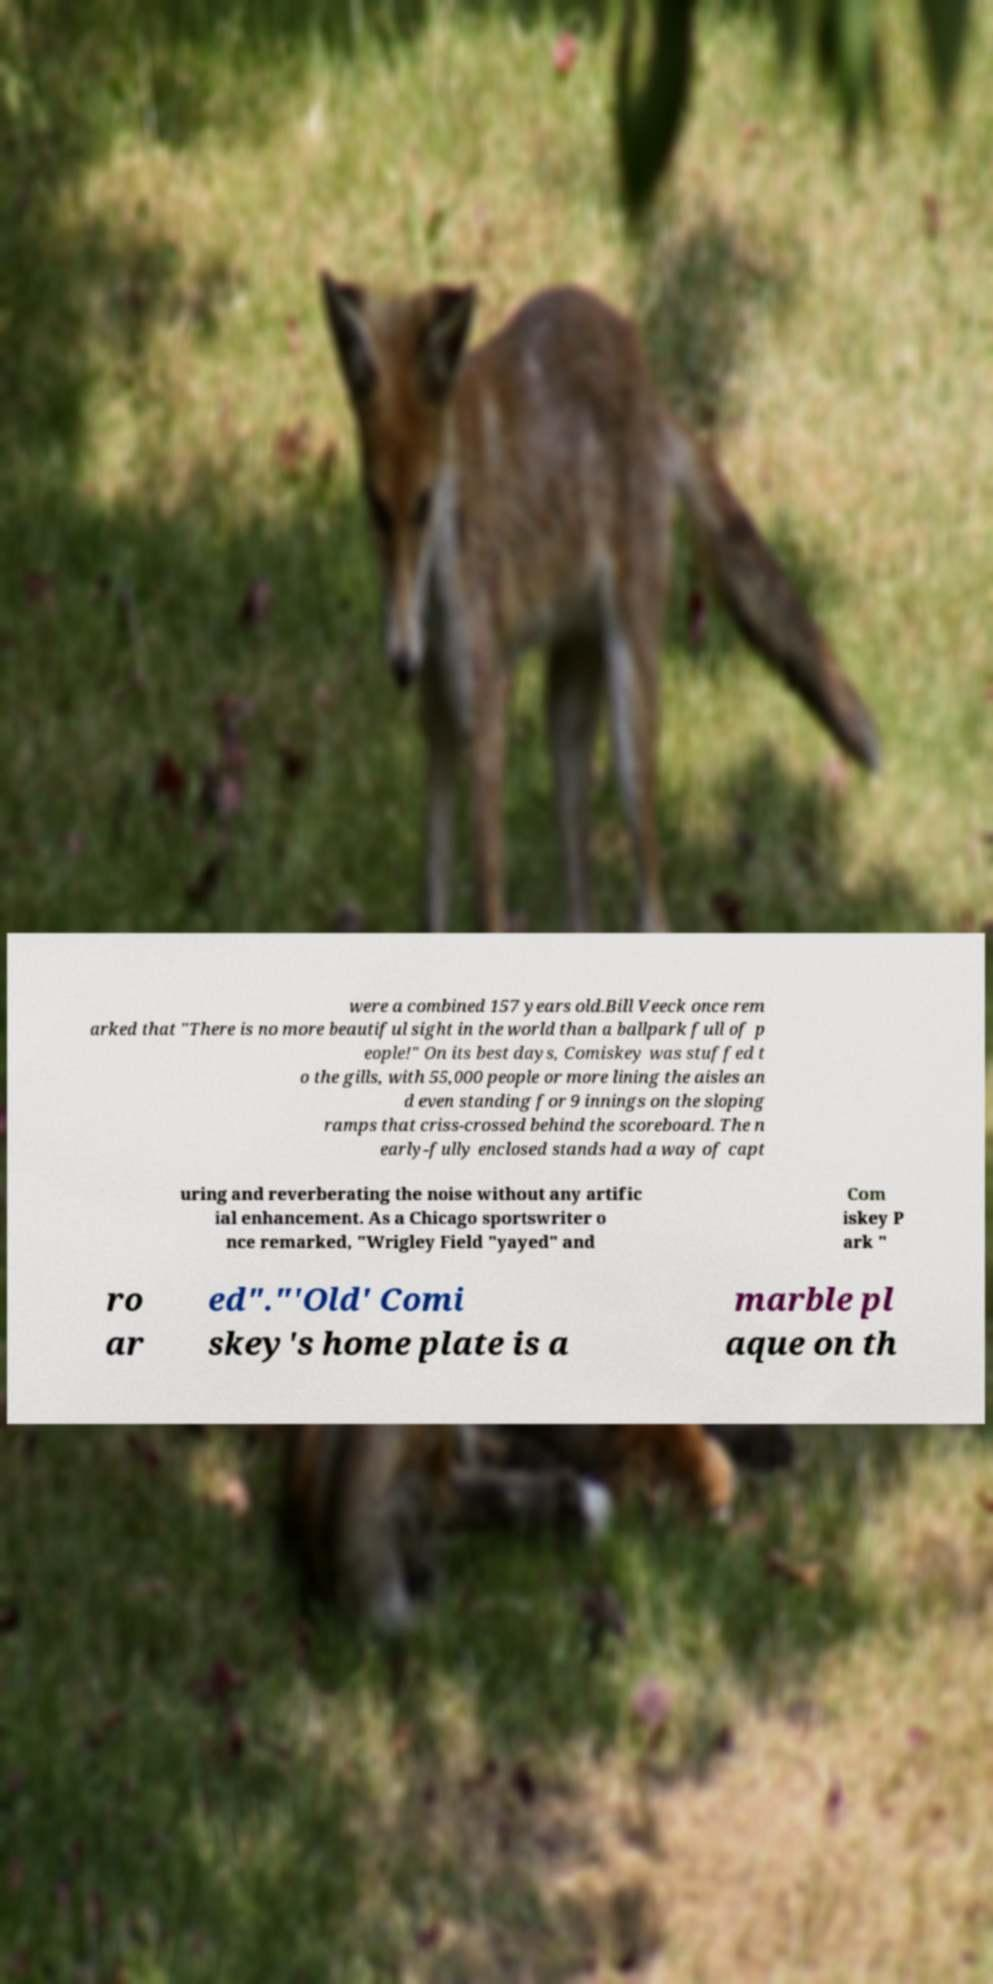There's text embedded in this image that I need extracted. Can you transcribe it verbatim? were a combined 157 years old.Bill Veeck once rem arked that "There is no more beautiful sight in the world than a ballpark full of p eople!" On its best days, Comiskey was stuffed t o the gills, with 55,000 people or more lining the aisles an d even standing for 9 innings on the sloping ramps that criss-crossed behind the scoreboard. The n early-fully enclosed stands had a way of capt uring and reverberating the noise without any artific ial enhancement. As a Chicago sportswriter o nce remarked, "Wrigley Field "yayed" and Com iskey P ark " ro ar ed"."'Old' Comi skey's home plate is a marble pl aque on th 